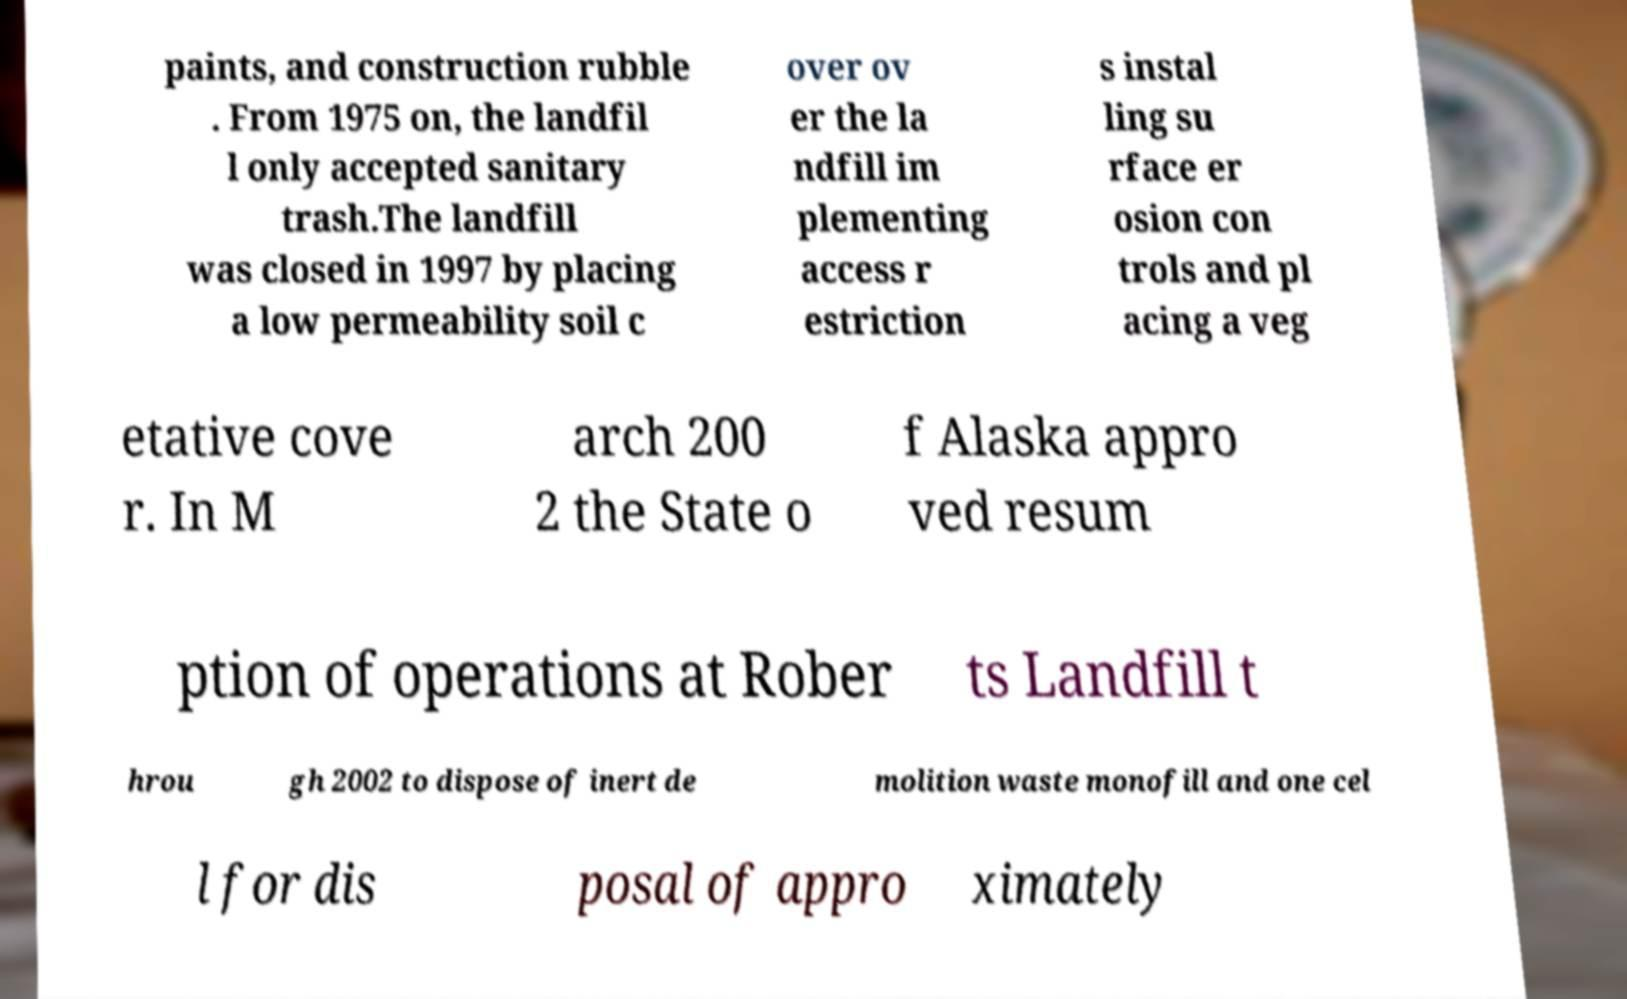For documentation purposes, I need the text within this image transcribed. Could you provide that? paints, and construction rubble . From 1975 on, the landfil l only accepted sanitary trash.The landfill was closed in 1997 by placing a low permeability soil c over ov er the la ndfill im plementing access r estriction s instal ling su rface er osion con trols and pl acing a veg etative cove r. In M arch 200 2 the State o f Alaska appro ved resum ption of operations at Rober ts Landfill t hrou gh 2002 to dispose of inert de molition waste monofill and one cel l for dis posal of appro ximately 